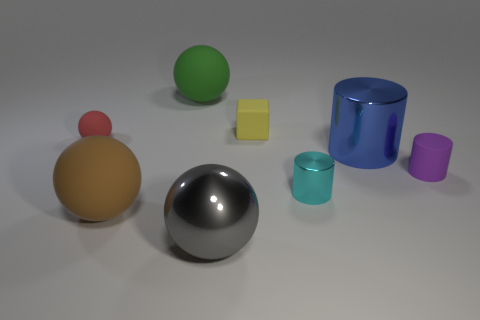Add 1 tiny yellow objects. How many objects exist? 9 Subtract all cylinders. How many objects are left? 5 Add 5 large green rubber balls. How many large green rubber balls are left? 6 Add 7 small red rubber spheres. How many small red rubber spheres exist? 8 Subtract 0 blue blocks. How many objects are left? 8 Subtract all small objects. Subtract all gray cylinders. How many objects are left? 4 